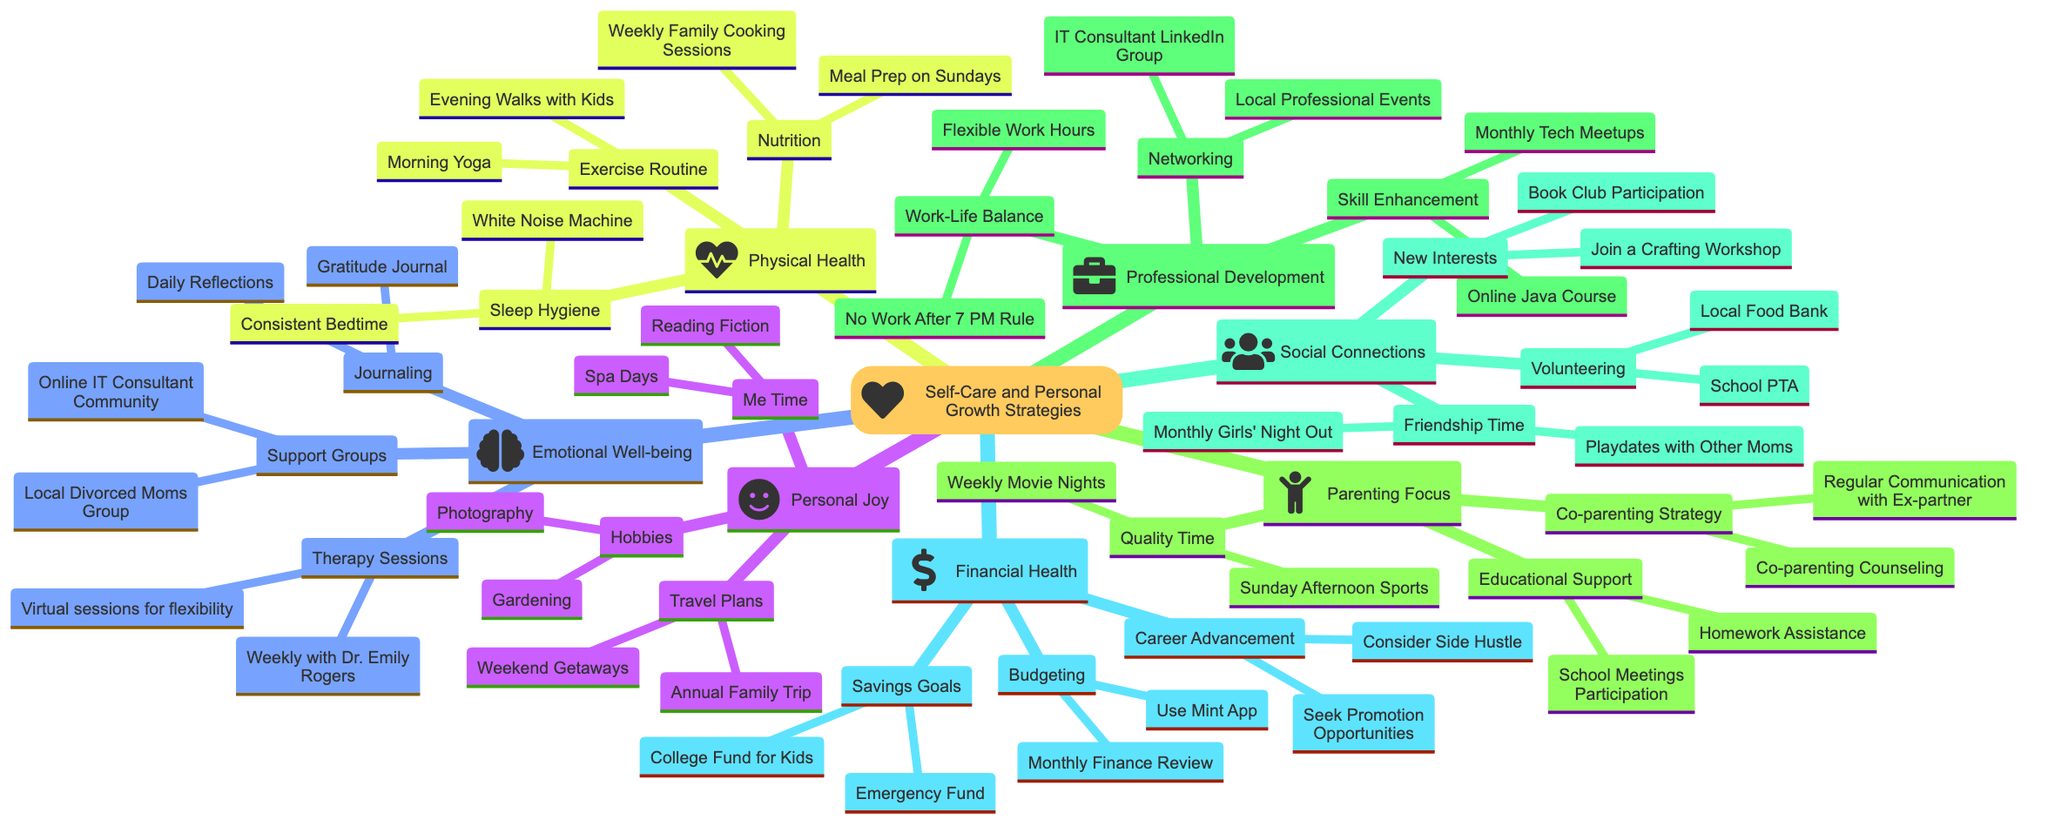What are the three main categories in the mind map? The mind map contains seven main categories: Emotional Well-being, Physical Health, Parenting Focus, Professional Development, Social Connections, Personal Joy, and Financial Health.
Answer: Emotional Well-being, Physical Health, Parenting Focus How many activities are listed under Personal Joy? The "Personal Joy" category has three subcategories: Hobbies, Me Time, and Travel Plans. Each subcategory includes specific activities totaling to six activities.
Answer: Six What is one method suggested for improving Emotional Well-being? In the "Emotional Well-being" category, one listed method for improvement is "Therapy Sessions." This is explicitly stated as a supportive action in the mind map.
Answer: Therapy Sessions Which category includes activities related to relationships with children? The "Parenting Focus" category focuses on activities related to relationships with children, detailing quality time spent and strategies for co-parenting.
Answer: Parenting Focus What are the two activities listed under the Nutrition subcategory? The subcategory "Nutrition" lists two activities: "Meal Prep on Sundays" and "Weekly Family Cooking Sessions." These are directly mentioned under the Nutrition heading in the mind map.
Answer: Meal Prep on Sundays, Weekly Family Cooking Sessions How many supports are mentioned under the Support Groups? The "Support Groups" in the "Emotional Well-being" category lists two groups: "Local Divorced Moms Group" and "Online IT Consultant Community." This provides specific details regarding available support networks.
Answer: Two What connection exists between Professional Development and Skill Enhancement? The "Professional Development" category contains a subcategory called "Skill Enhancement," which is directly connected. The relationship is hierarchical, with "Skill Enhancement" being a component of "Professional Development."
Answer: Skill Enhancement What is a suggested activity in the Social Connections category? In the "Social Connections" category, "Friendship Time" details activities like "Monthly Girls' Night Out," indicating an action that helps foster social ties and connections.
Answer: Monthly Girls' Night Out 